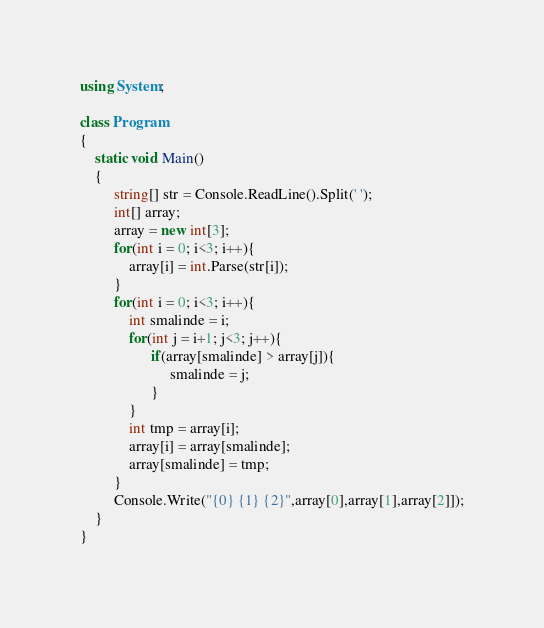<code> <loc_0><loc_0><loc_500><loc_500><_C#_>using System;

class Program
{
    static void Main()
    {    
         string[] str = Console.ReadLine().Split(' ');
         int[] array;
         array = new int[3];
         for(int i = 0; i<3; i++){
             array[i] = int.Parse(str[i]);
         }
         for(int i = 0; i<3; i++){
             int smalinde = i;
             for(int j = i+1; j<3; j++){
                   if(array[smalinde] > array[j]){
                        smalinde = j;
                   }
             }
             int tmp = array[i];
             array[i] = array[smalinde];
             array[smalinde] = tmp;
         }
         Console.Write("{0} {1} {2}",array[0],array[1],array[2]]);
    }
}</code> 